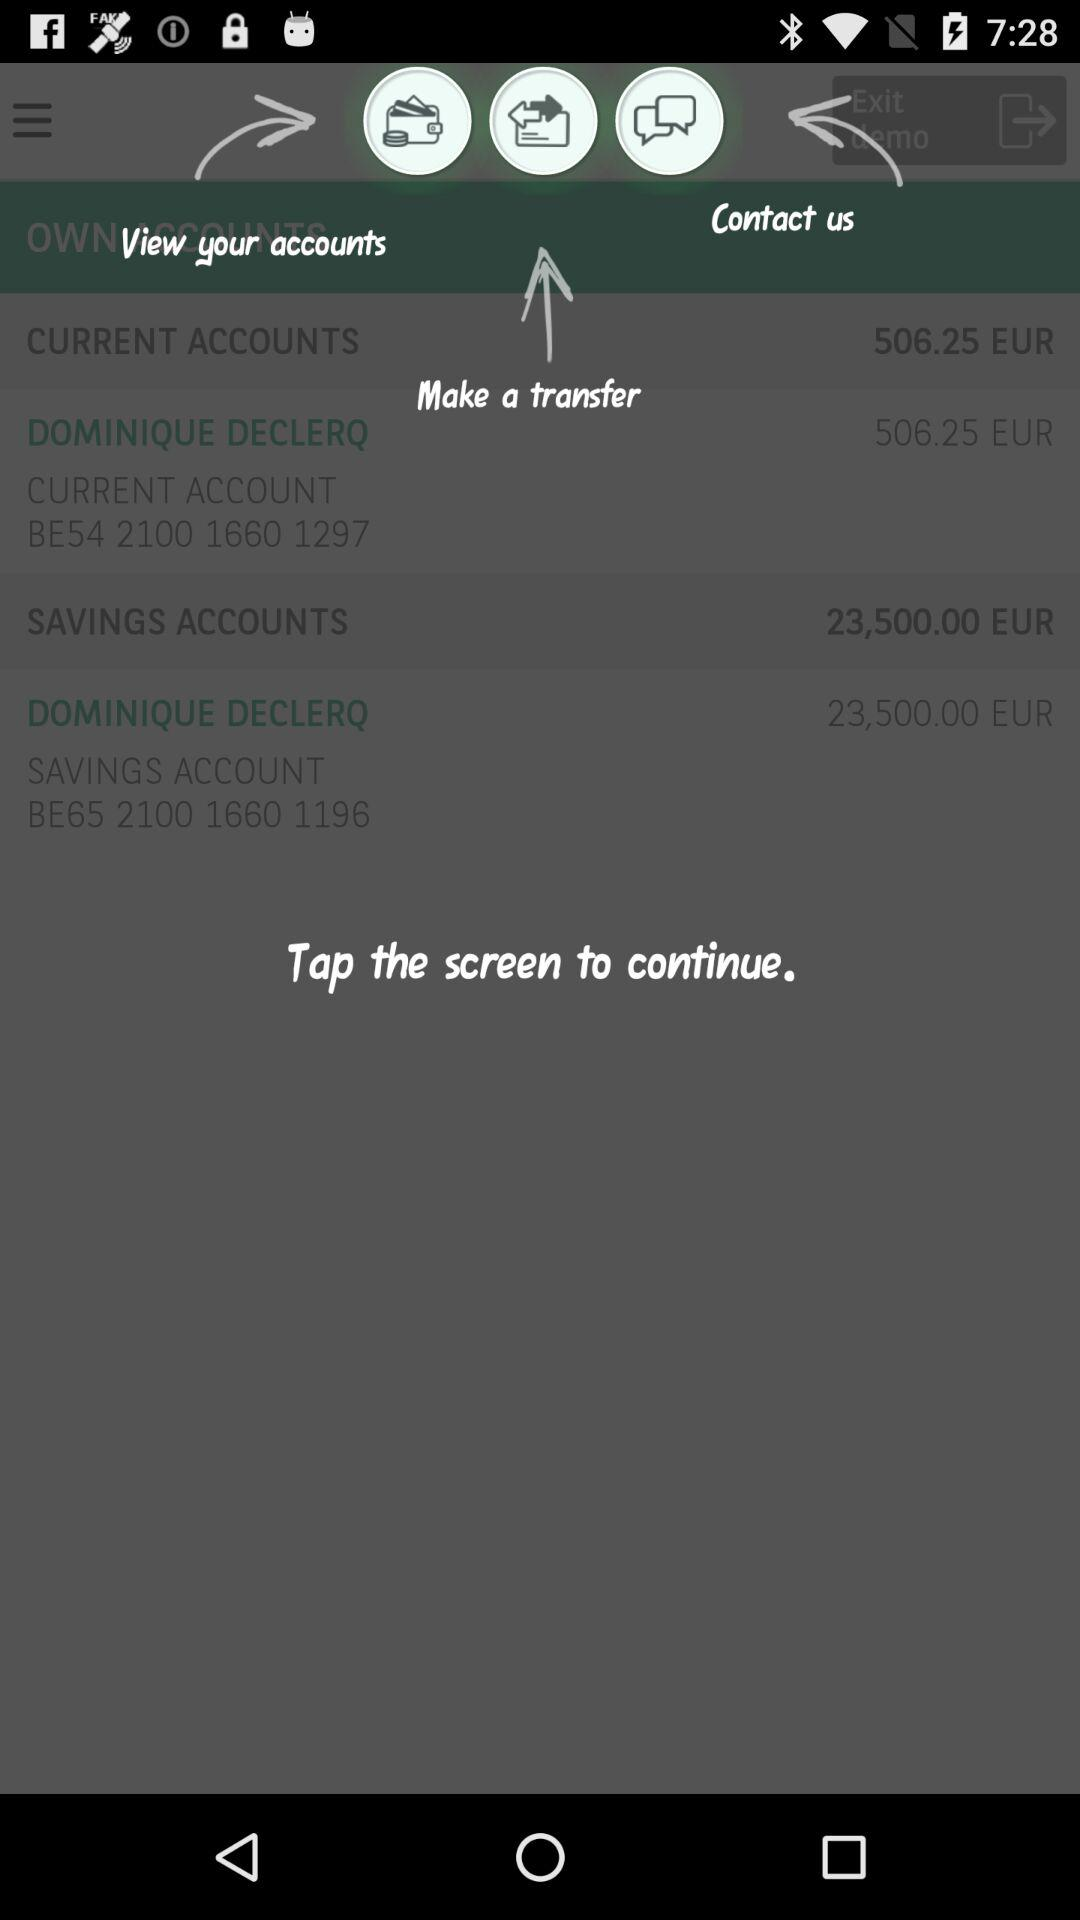How many accounts does Dominique Declercq have?
Answer the question using a single word or phrase. 2 